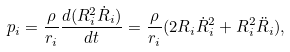Convert formula to latex. <formula><loc_0><loc_0><loc_500><loc_500>p _ { i } = \frac { \rho } { r _ { i } } \frac { d ( R _ { i } ^ { 2 } \dot { R } _ { i } ) } { d t } = \frac { \rho } { r _ { i } } ( 2 R _ { i } \dot { R } _ { i } ^ { 2 } + R _ { i } ^ { 2 } \ddot { R } _ { i } ) ,</formula> 